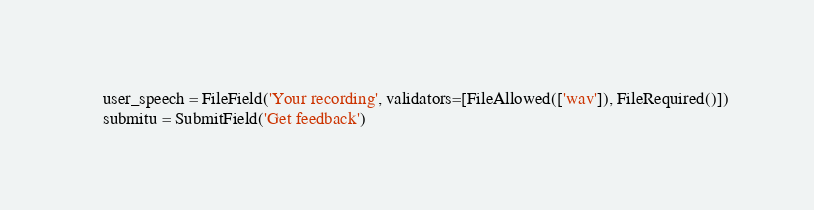Convert code to text. <code><loc_0><loc_0><loc_500><loc_500><_Python_>    user_speech = FileField('Your recording', validators=[FileAllowed(['wav']), FileRequired()])
    submitu = SubmitField('Get feedback')
</code> 